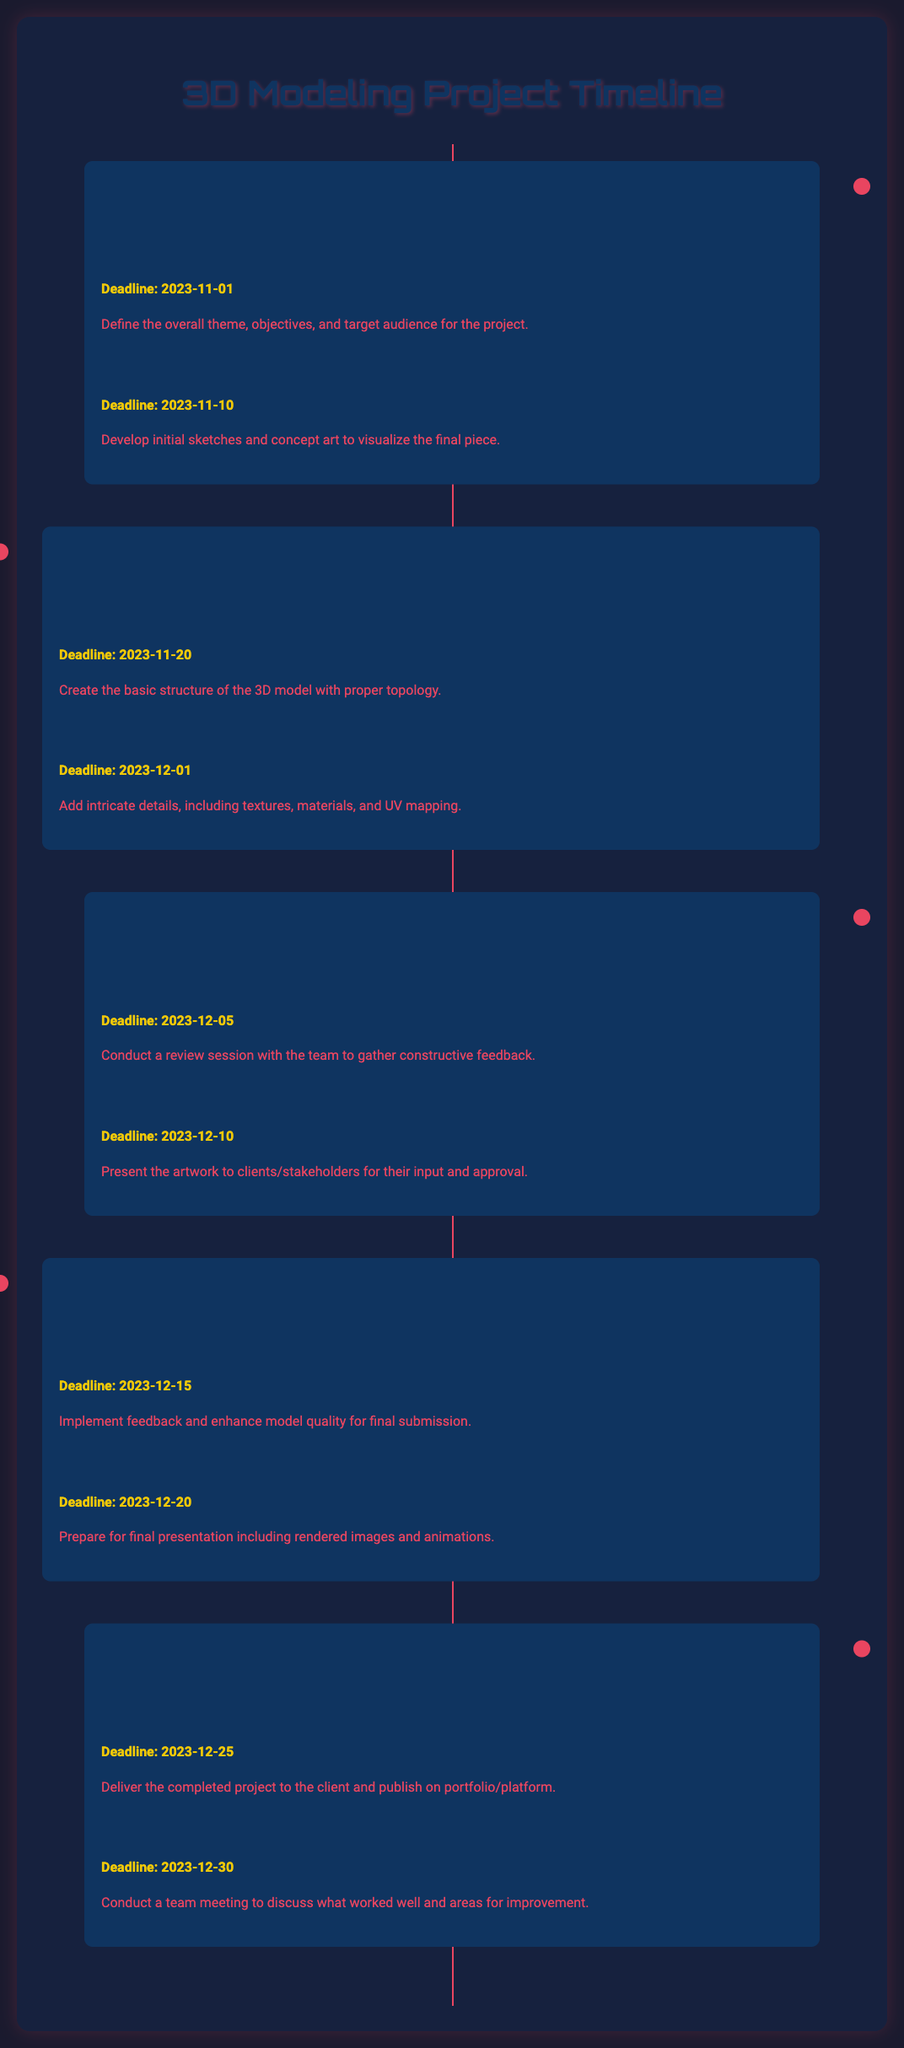What is the deadline for Project Scope Definition? The deadline for Project Scope Definition can be found in the Planning phase, which is listed as 2023-11-01.
Answer: 2023-11-01 How many milestones are in the Modeling phase? The Modeling phase includes two milestones: Base Mesh Creation and Detailing the Model.
Answer: 2 What is the purpose of the Post-Mortem Review? The Post-Mortem Review is designed to discuss what worked well and areas for improvement, as mentioned in the Completion phase.
Answer: Improvement When is the Client Feedback Session scheduled? The date for the Client Feedback Session can be found in the Review and Feedback phase, which is 2023-12-10.
Answer: 2023-12-10 Which phase includes the milestone "Polishing the Model"? The milestone "Polishing the Model" can be found in the Finalization phase of the project timeline.
Answer: Finalization What is the last milestone listed in the timeline? The last milestone in the timeline is the Post-Mortem Review, which occurs on 2023-12-30.
Answer: Post-Mortem Review What color is used for the timeline background? The timeline background is created with the color #16213e as per the container's style in the document.
Answer: #16213e How many phases are there in the document? The document details five distinct phases in the project timeline.
Answer: 5 What is the deadline for Project Delivery? The deadline for the Project Delivery is specified as 2023-12-25 in the Completion phase.
Answer: 2023-12-25 